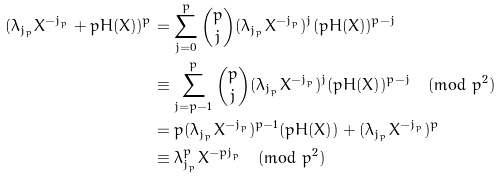<formula> <loc_0><loc_0><loc_500><loc_500>( \lambda _ { j _ { p } } X ^ { - j _ { p } } + p H ( X ) ) ^ { p } & = \sum ^ { p } _ { j = 0 } \binom { p } { j } ( \lambda _ { j _ { p } } X ^ { - j _ { p } } ) ^ { j } ( p H ( X ) ) ^ { p - j } \\ & \equiv \sum ^ { p } _ { j = p - 1 } \binom { p } { j } ( \lambda _ { j _ { p } } X ^ { - j _ { p } } ) ^ { j } ( p H ( X ) ) ^ { p - j } \pmod { p ^ { 2 } } \\ & = p ( \lambda _ { j _ { p } } X ^ { - j _ { p } } ) ^ { p - 1 } ( p H ( X ) ) + ( \lambda _ { j _ { p } } X ^ { - j _ { p } } ) ^ { p } \\ & \equiv \lambda _ { j _ { p } } ^ { p } X ^ { - p j _ { p } } \pmod { p ^ { 2 } }</formula> 